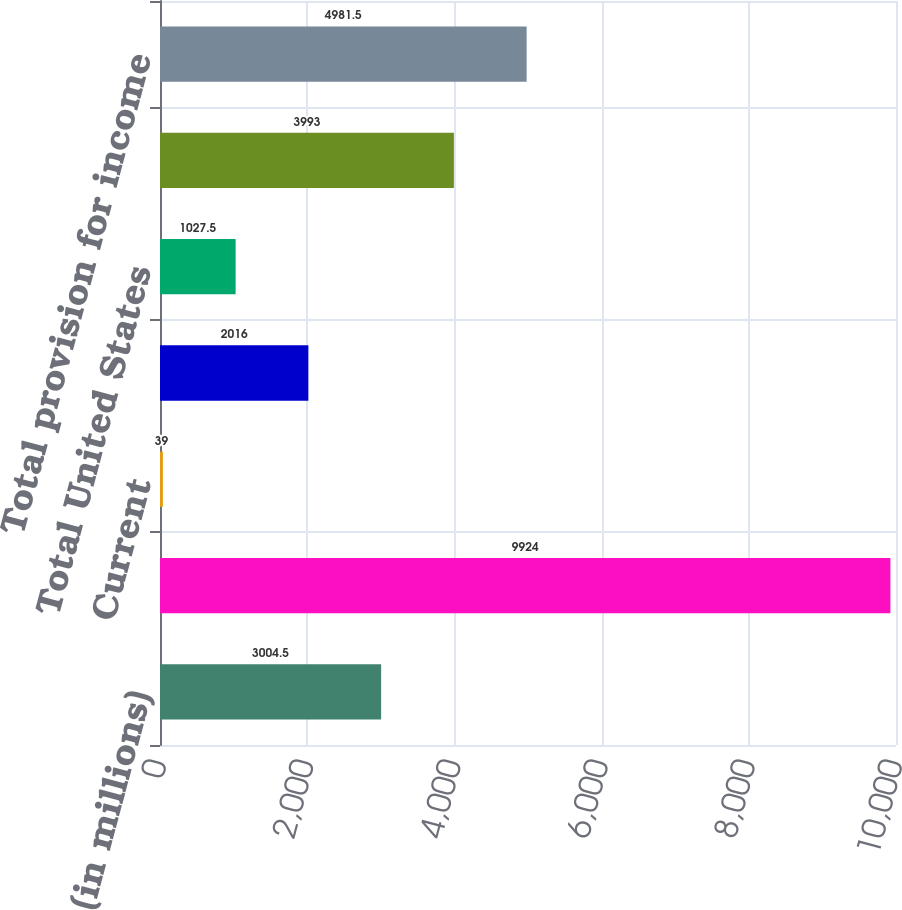Convert chart. <chart><loc_0><loc_0><loc_500><loc_500><bar_chart><fcel>(in millions)<fcel>Earnings before income taxes<fcel>Current<fcel>Deferred<fcel>Total United States<fcel>Total outside United States<fcel>Total provision for income<nl><fcel>3004.5<fcel>9924<fcel>39<fcel>2016<fcel>1027.5<fcel>3993<fcel>4981.5<nl></chart> 